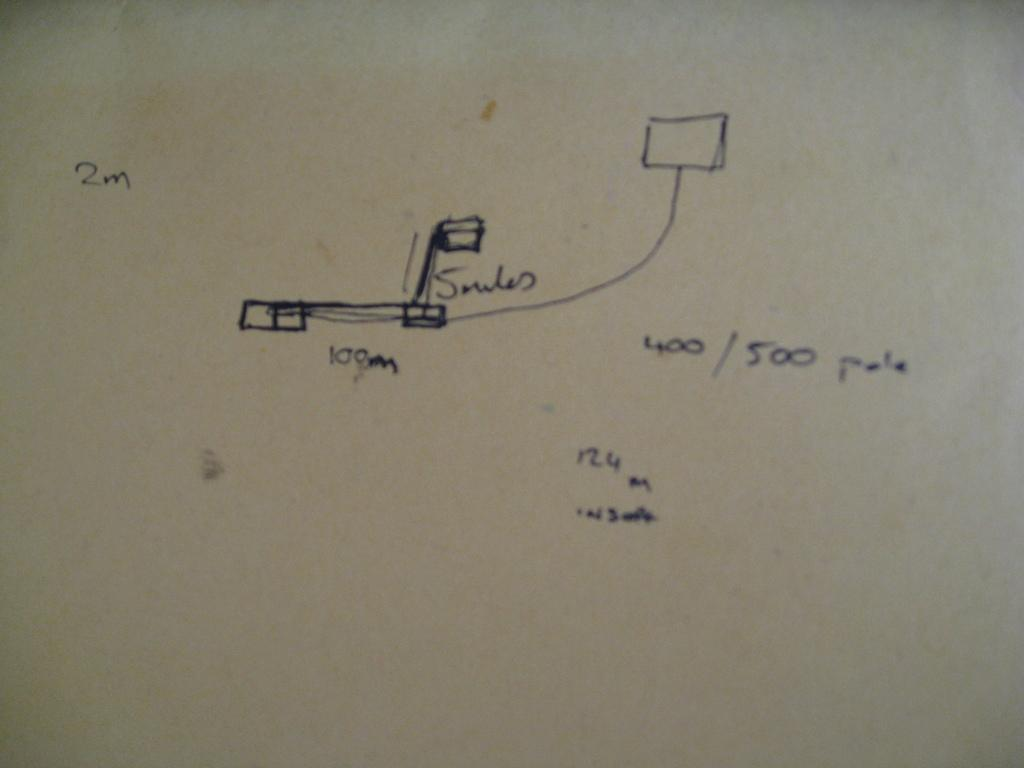<image>
Give a short and clear explanation of the subsequent image. A drawing of measurements of an item including 100m, 2m, and a 400/500 pole. 